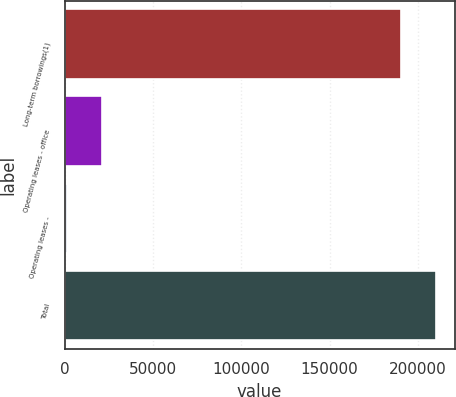Convert chart. <chart><loc_0><loc_0><loc_500><loc_500><bar_chart><fcel>Long-term borrowings(1)<fcel>Operating leases - office<fcel>Operating leases -<fcel>Total<nl><fcel>190624<fcel>21139.1<fcel>1552<fcel>210211<nl></chart> 